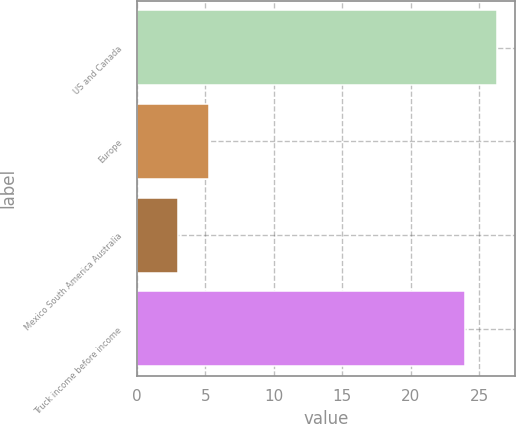Convert chart. <chart><loc_0><loc_0><loc_500><loc_500><bar_chart><fcel>US and Canada<fcel>Europe<fcel>Mexico South America Australia<fcel>Truck income before income<nl><fcel>26.3<fcel>5.3<fcel>3<fcel>24<nl></chart> 